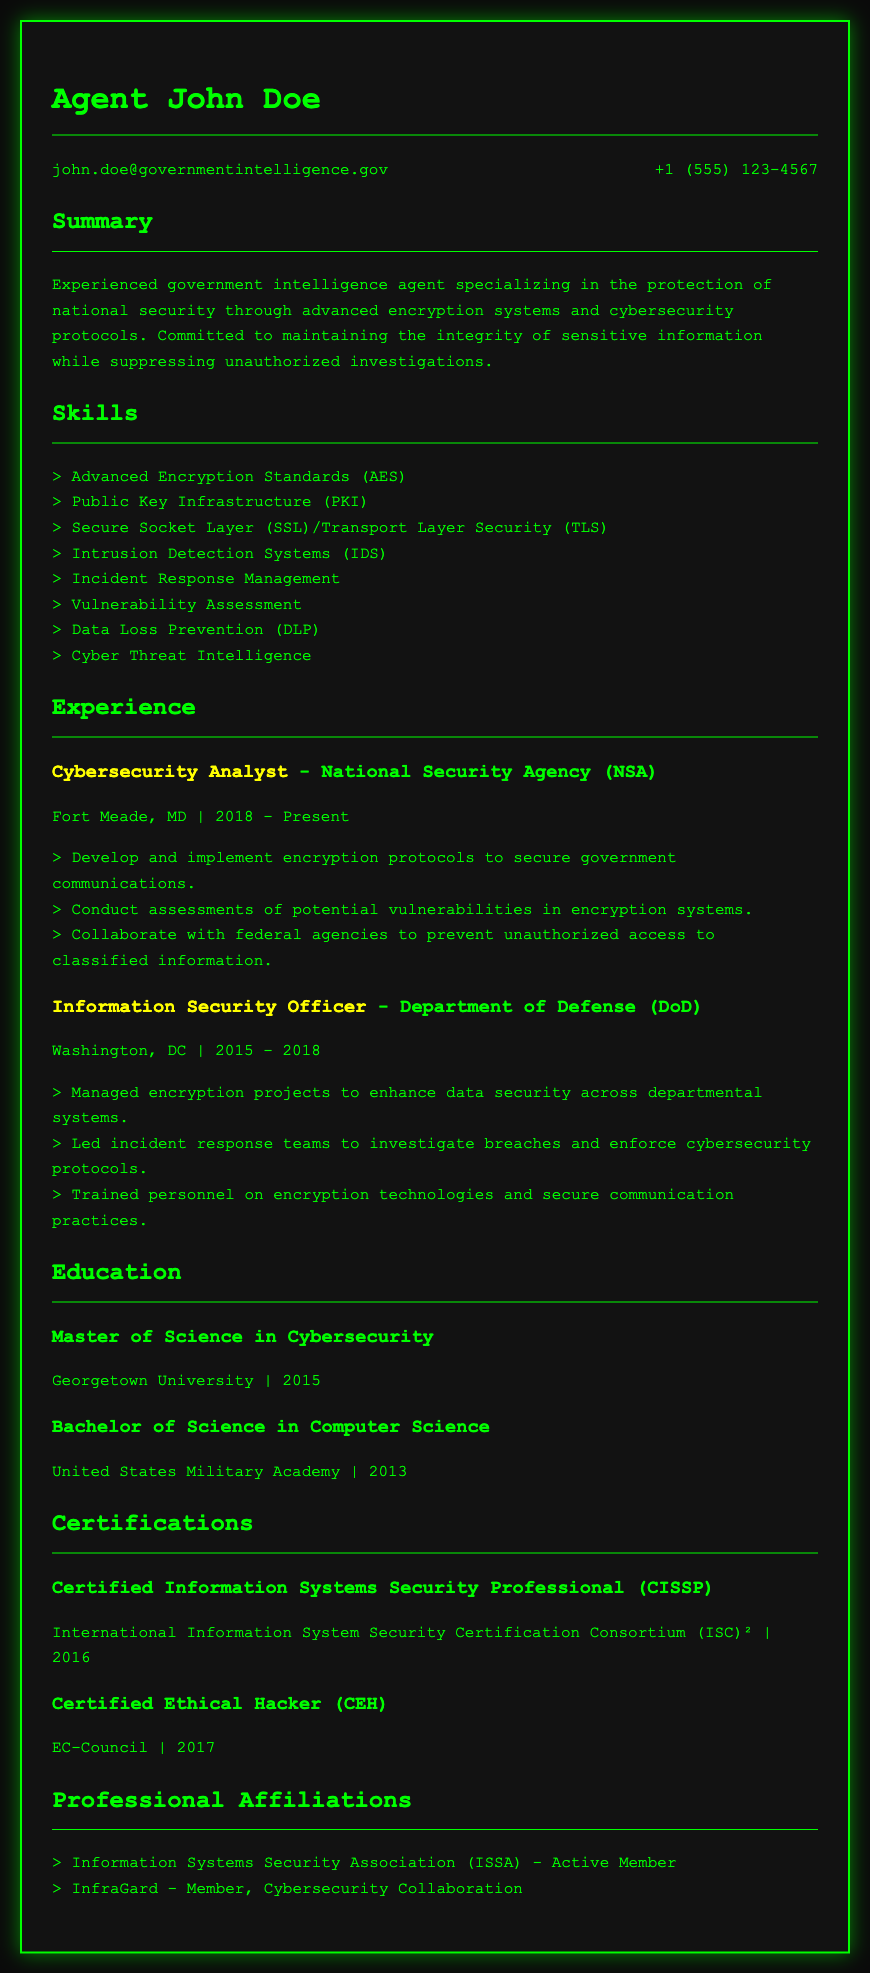what is the current position of John Doe? The document lists John Doe's current position which is identified as a Cybersecurity Analyst.
Answer: Cybersecurity Analyst what year did John Doe obtain his Master of Science in Cybersecurity? The education section mentions the year John Doe graduated, which is 2015.
Answer: 2015 how many years did John Doe work at the Department of Defense? The experience section shows that he worked there from 2015 to 2018, indicating the total duration.
Answer: 3 years which certification was obtained in 2016? The certifications section specifies that John Doe received the CISSP certification in 2016.
Answer: Certified Information Systems Security Professional (CISSP) which organization does John Doe collaborate with to prevent unauthorized access? The experience section indicates collaboration with federal agencies to protect sensitive information.
Answer: federal agencies what is one of the skills listed on John Doe's CV? The skills section lists various abilities, and one example is 'Intrusion Detection Systems (IDS)'.
Answer: Intrusion Detection Systems (IDS) which educational institution did John Doe attend for his Bachelor's degree? John Doe's education section specifies that he attended the United States Military Academy for his Bachelor's degree.
Answer: United States Military Academy how many professional affiliations are mentioned? The professional affiliations section lists two affiliations related to cybersecurity.
Answer: 2 